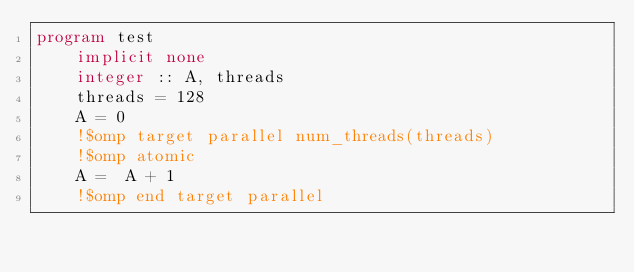Convert code to text. <code><loc_0><loc_0><loc_500><loc_500><_FORTRAN_>program test
    implicit none
    integer :: A, threads
    threads = 128
    A = 0
    !$omp target parallel num_threads(threads)
    !$omp atomic
    A =  A + 1
    !$omp end target parallel</code> 